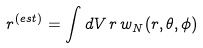Convert formula to latex. <formula><loc_0><loc_0><loc_500><loc_500>r ^ { ( e s t ) } = \int d V \, r \, w _ { N } ( r , \theta , \phi )</formula> 